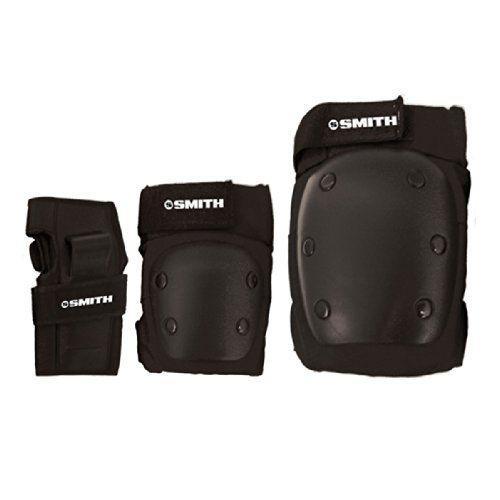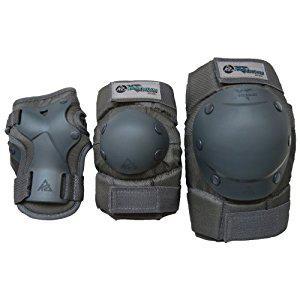The first image is the image on the left, the second image is the image on the right. For the images displayed, is the sentence "The image on the right has 3 objects arranged from smallest to largest." factually correct? Answer yes or no. Yes. 